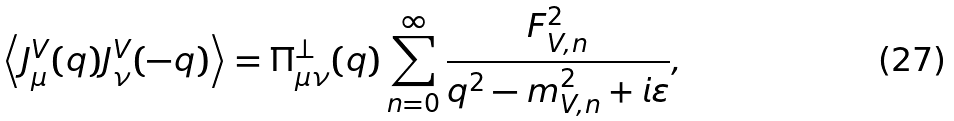<formula> <loc_0><loc_0><loc_500><loc_500>\left \langle J _ { \mu } ^ { V } ( q ) J _ { \nu } ^ { V } ( - q ) \right \rangle = \Pi _ { \mu \nu } ^ { \perp } ( q ) \sum _ { n = 0 } ^ { \infty } \frac { F _ { V , n } ^ { 2 } } { q ^ { 2 } - m _ { V , n } ^ { 2 } + i \varepsilon } ,</formula> 